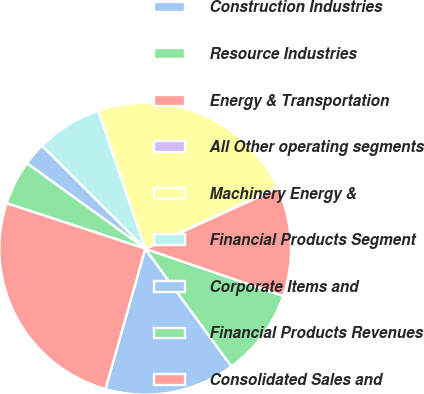Convert chart. <chart><loc_0><loc_0><loc_500><loc_500><pie_chart><fcel>Construction Industries<fcel>Resource Industries<fcel>Energy & Transportation<fcel>All Other operating segments<fcel>Machinery Energy &<fcel>Financial Products Segment<fcel>Corporate Items and<fcel>Financial Products Revenues<fcel>Consolidated Sales and<nl><fcel>14.46%<fcel>9.68%<fcel>12.07%<fcel>0.13%<fcel>23.27%<fcel>7.3%<fcel>2.52%<fcel>4.91%<fcel>25.65%<nl></chart> 